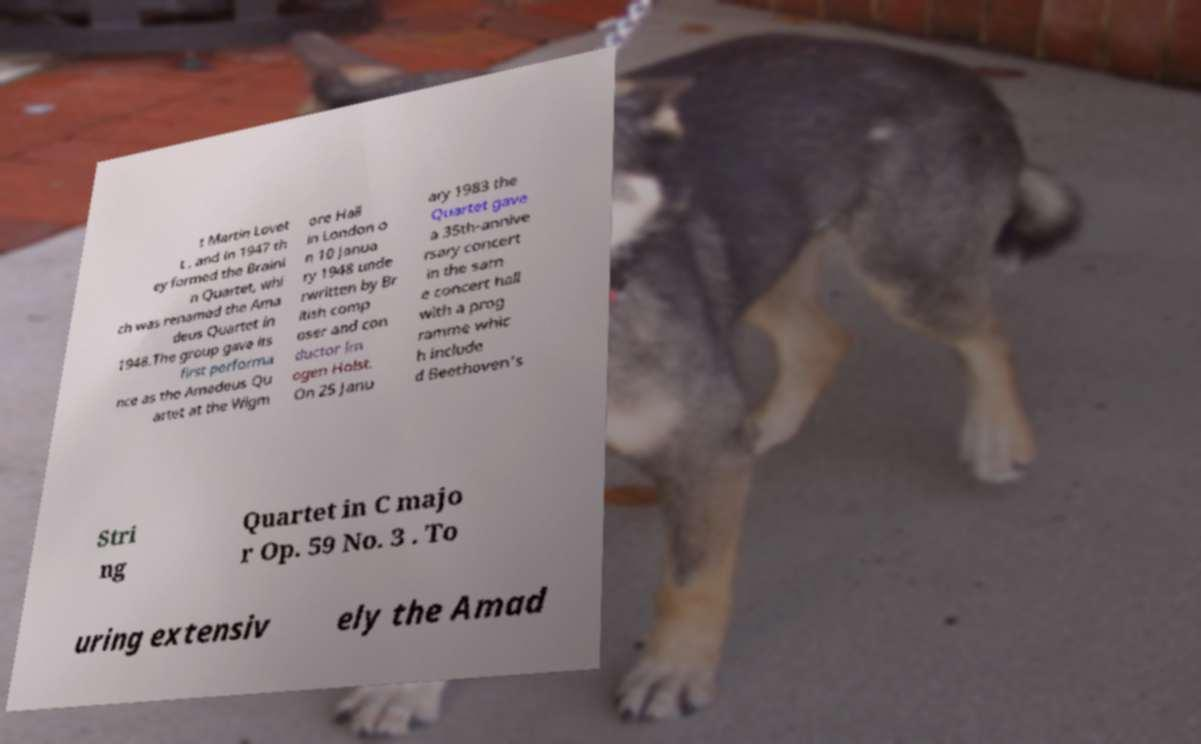For documentation purposes, I need the text within this image transcribed. Could you provide that? t Martin Lovet t , and in 1947 th ey formed the Braini n Quartet, whi ch was renamed the Ama deus Quartet in 1948.The group gave its first performa nce as the Amadeus Qu artet at the Wigm ore Hall in London o n 10 Janua ry 1948 unde rwritten by Br itish comp oser and con ductor Im ogen Holst. On 25 Janu ary 1983 the Quartet gave a 35th-annive rsary concert in the sam e concert hall with a prog ramme whic h include d Beethoven's Stri ng Quartet in C majo r Op. 59 No. 3 . To uring extensiv ely the Amad 